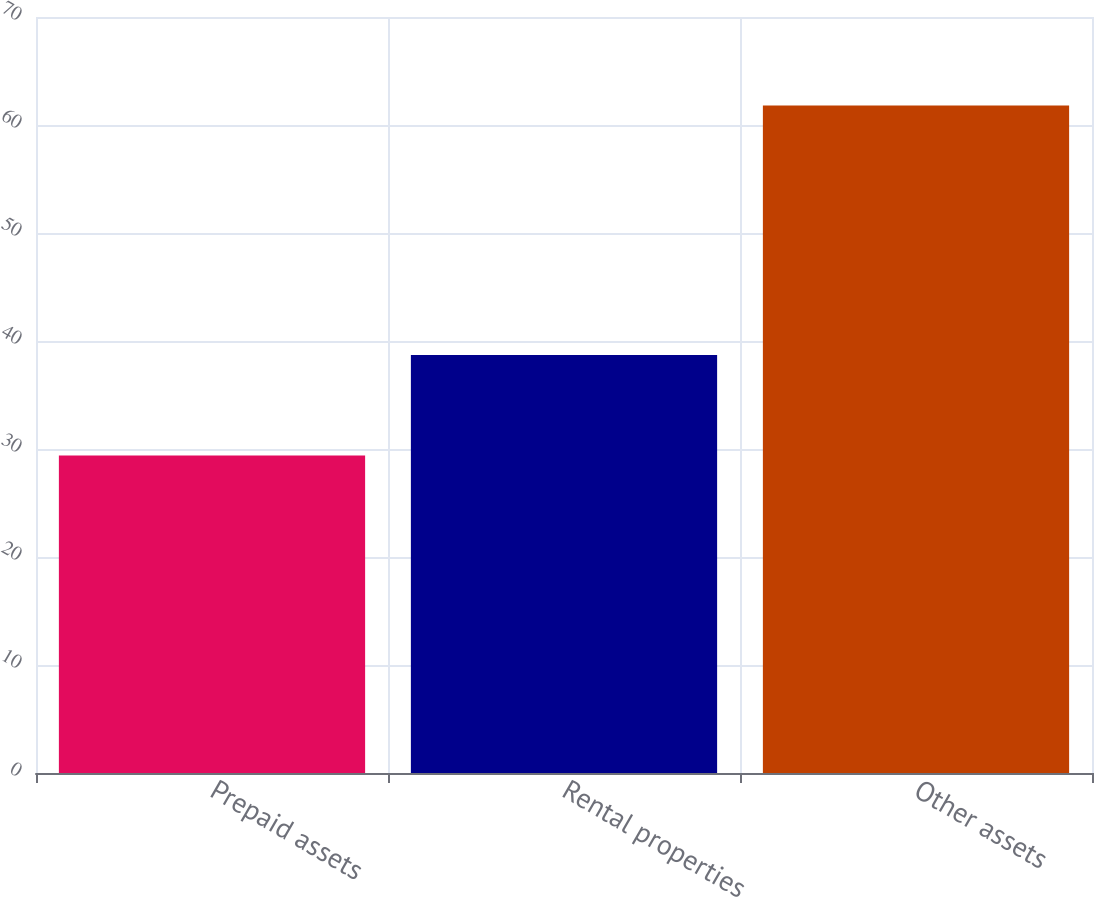<chart> <loc_0><loc_0><loc_500><loc_500><bar_chart><fcel>Prepaid assets<fcel>Rental properties<fcel>Other assets<nl><fcel>29.4<fcel>38.7<fcel>61.8<nl></chart> 